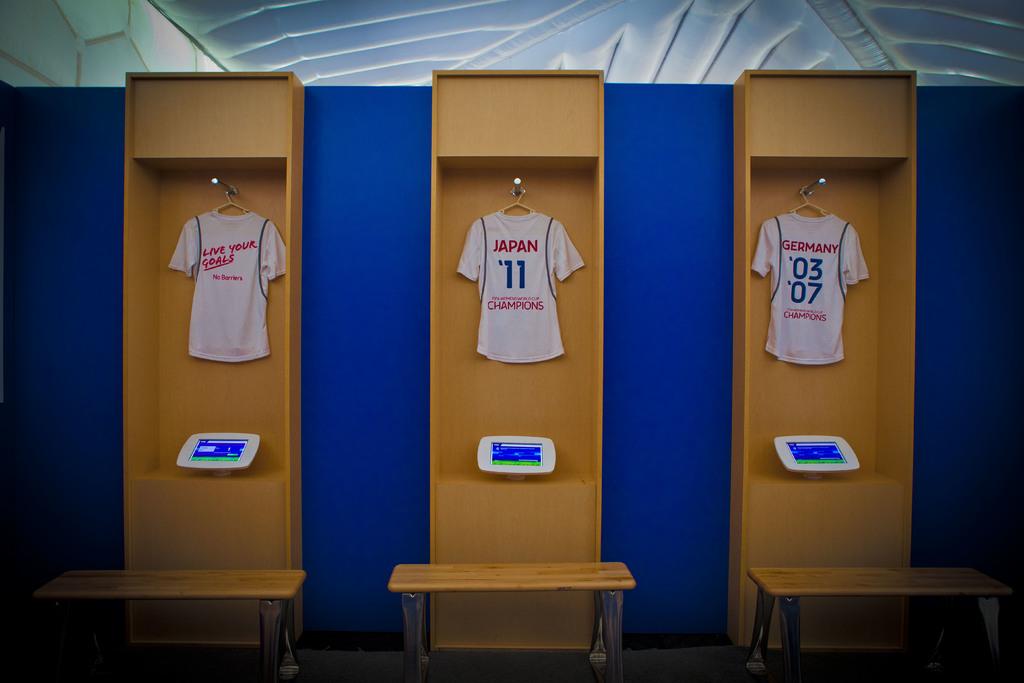The number on the middle jersey is?
Provide a succinct answer. 11. 